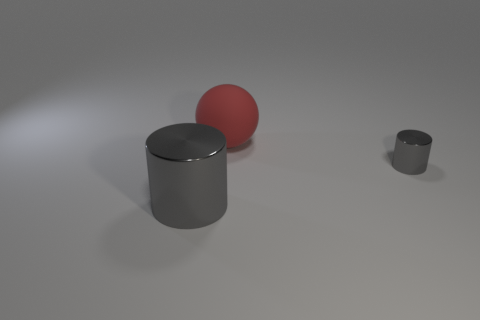Is there anything else that has the same material as the red thing?
Offer a terse response. No. There is a object that is the same color as the large cylinder; what is its shape?
Give a very brief answer. Cylinder. The other object that is the same material as the small thing is what shape?
Keep it short and to the point. Cylinder. Do the cylinder right of the large gray thing and the metal object that is in front of the small gray cylinder have the same color?
Provide a succinct answer. Yes. Is the number of large gray cylinders behind the tiny gray thing the same as the number of objects?
Your response must be concise. No. What number of metal objects are in front of the small gray metallic cylinder?
Provide a succinct answer. 1. What is the color of the small cylinder that is made of the same material as the big gray cylinder?
Ensure brevity in your answer.  Gray. How many other objects are the same size as the red matte thing?
Offer a very short reply. 1. Do the gray thing that is on the right side of the matte sphere and the big cylinder have the same material?
Offer a very short reply. Yes. Are there fewer gray shiny cylinders that are right of the small metal thing than large blue spheres?
Offer a terse response. No. 